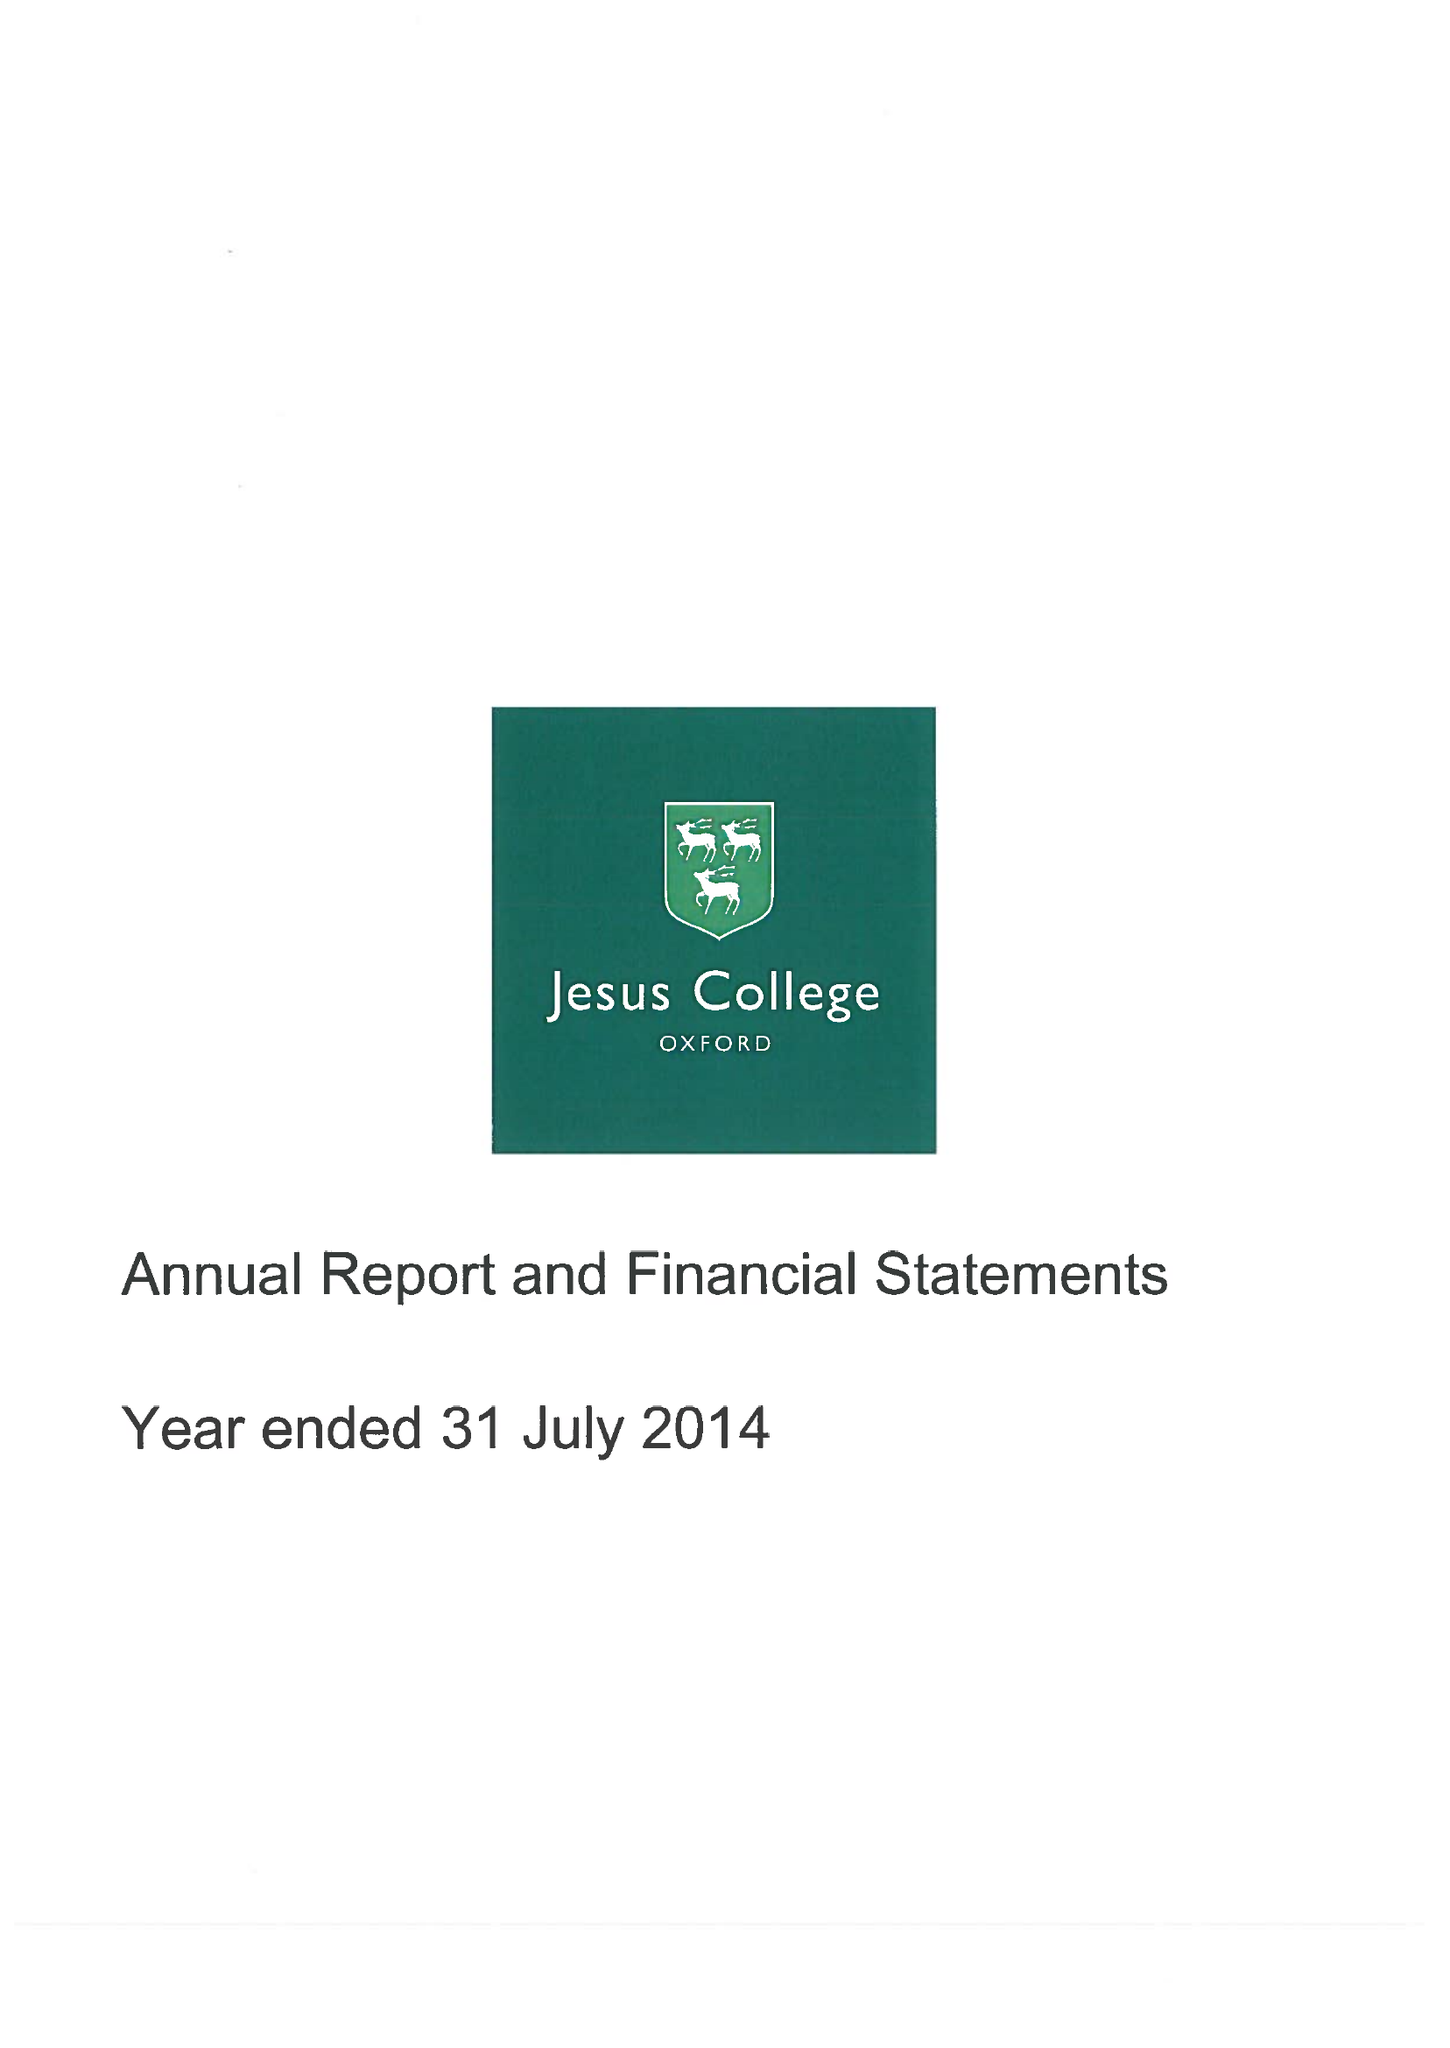What is the value for the address__post_town?
Answer the question using a single word or phrase. OXFORD 